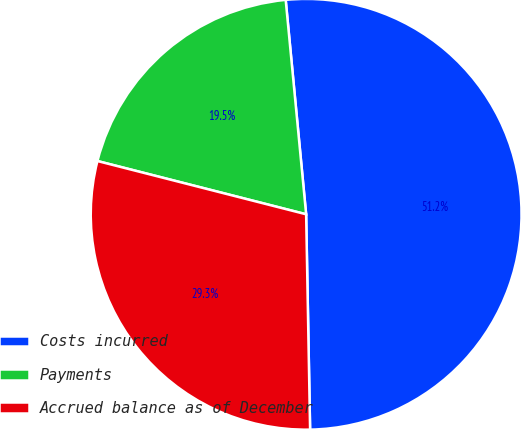<chart> <loc_0><loc_0><loc_500><loc_500><pie_chart><fcel>Costs incurred<fcel>Payments<fcel>Accrued balance as of December<nl><fcel>51.22%<fcel>19.51%<fcel>29.27%<nl></chart> 